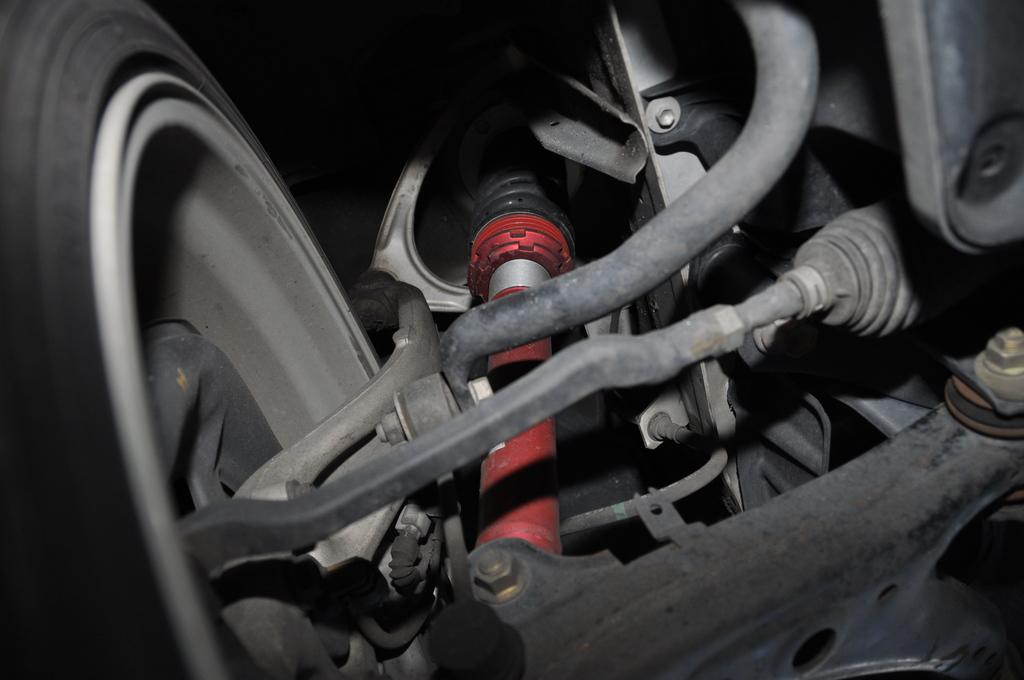What object is located on the left side of the image? There is a car tire on the left side of the image. What feature can be seen on the car tire? The car tire has shock absorbers. What object is on the right side of the image? There is a casing on the right side of the image. What is the rate at which the skate is moving in the image? There is no skate present in the image, so it is not possible to determine the rate at which it might be moving. 